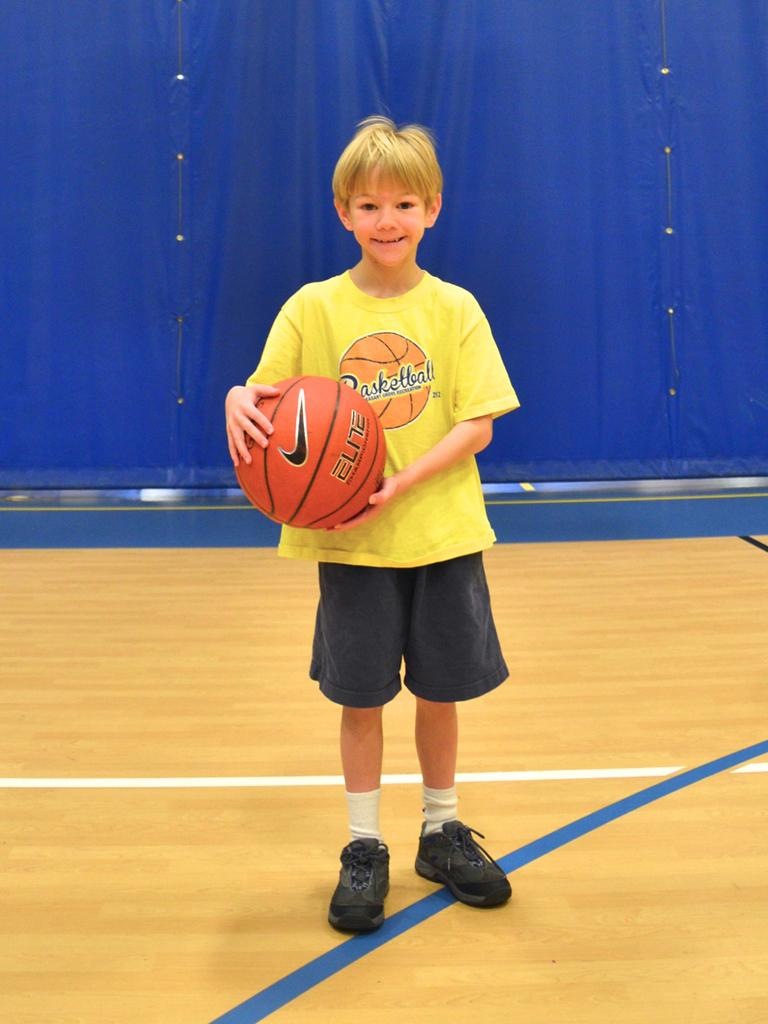Who is the main subject in the image? There is a boy in the image. What is the boy wearing? The boy is wearing a yellow t-shirt and black shorts. What is the boy holding in his hand? The boy is holding a ball in his hand. What color is the back curtain in the image? The back curtain is blue in color. What type of business is the boy conducting in the image? There is no indication of any business activity in the image; the boy is simply holding a ball. 